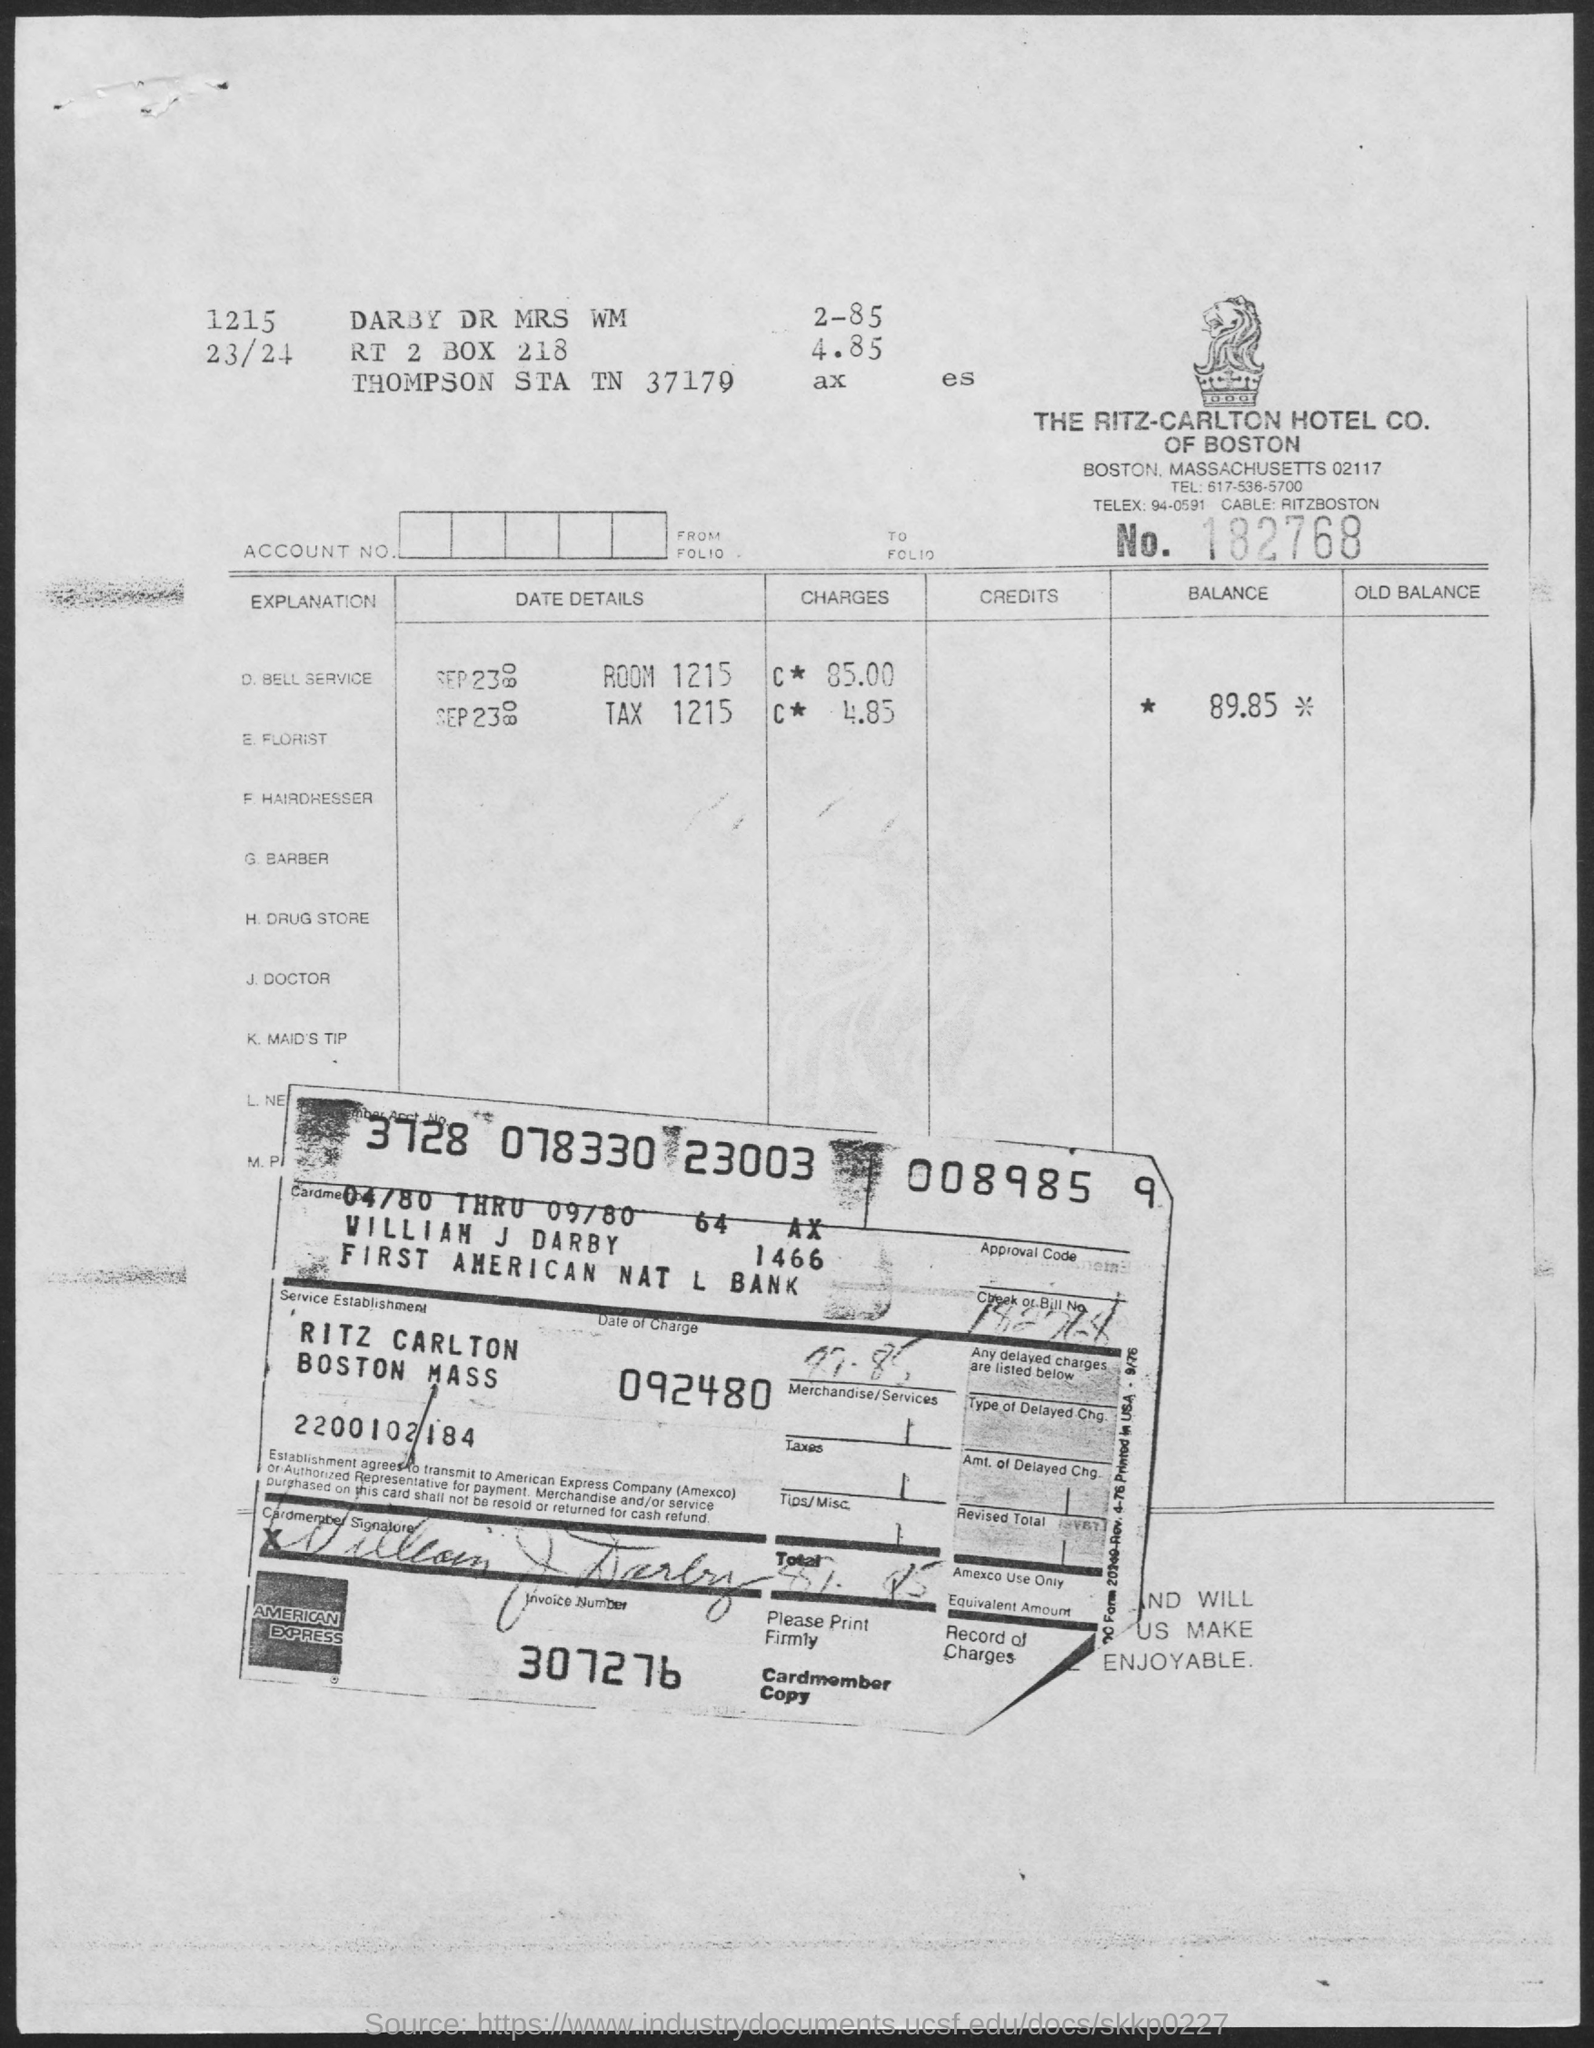What are the charges for the room 1215?
Provide a short and direct response. 85.00. What is the Balance?
Ensure brevity in your answer.  89.85. Who is the Cardmember?
Ensure brevity in your answer.  William J Darby. What is the Bank name?
Your answer should be very brief. First American Nat L Bank. What is the Invoice Number?
Offer a terse response. 307276. When is the Date of charge?
Provide a short and direct response. 092480. 